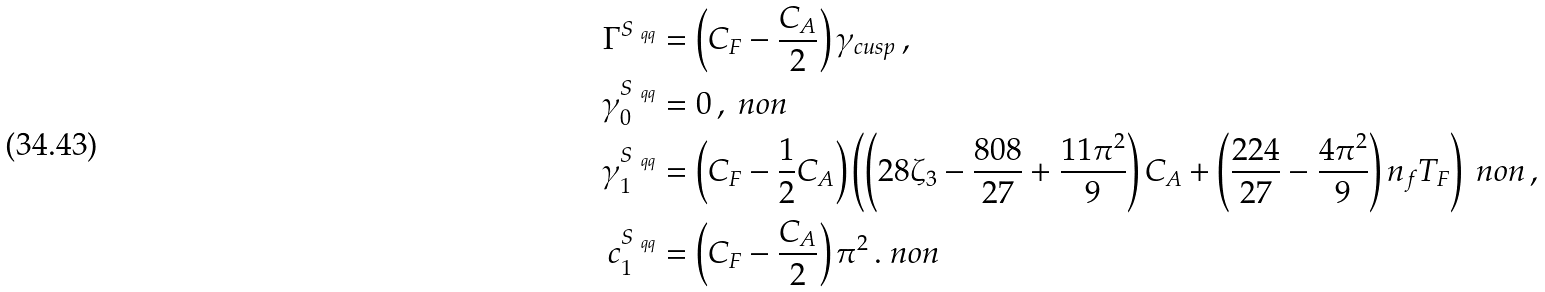Convert formula to latex. <formula><loc_0><loc_0><loc_500><loc_500>\Gamma ^ { S _ { \ q q } } & = \left ( C _ { F } - \frac { C _ { A } } { 2 } \right ) \gamma _ { c u s p } \, , \\ \gamma _ { 0 } ^ { S _ { \ q q } } & = 0 \, , \ n o n \\ \gamma _ { 1 } ^ { S _ { \ q q } } & = \left ( C _ { F } - \frac { 1 } { 2 } C _ { A } \right ) \left ( \left ( 2 8 \zeta _ { 3 } - \frac { 8 0 8 } { 2 7 } + \frac { 1 1 \pi ^ { 2 } } { 9 } \right ) C _ { A } + \left ( \frac { 2 2 4 } { 2 7 } - \frac { 4 \pi ^ { 2 } } { 9 } \right ) n _ { f } T _ { F } \right ) \ n o n \, , \\ c ^ { S _ { \ q q } } _ { 1 } & = \left ( C _ { F } - \frac { C _ { A } } { 2 } \right ) \pi ^ { 2 } \, . \ n o n</formula> 